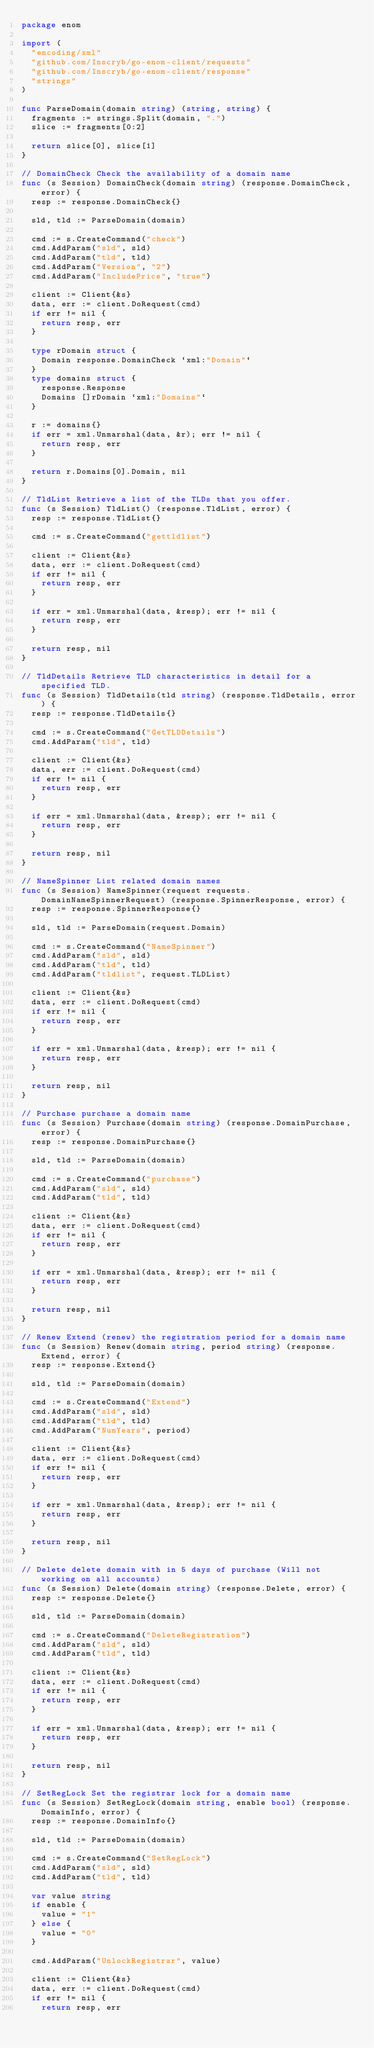Convert code to text. <code><loc_0><loc_0><loc_500><loc_500><_Go_>package enom

import (
	"encoding/xml"
	"github.com/Inscryb/go-enom-client/requests"
	"github.com/Inscryb/go-enom-client/response"
	"strings"
)

func ParseDomain(domain string) (string, string) {
	fragments := strings.Split(domain, ".")
	slice := fragments[0:2]

	return slice[0], slice[1]
}

// DomainCheck Check the availability of a domain name
func (s Session) DomainCheck(domain string) (response.DomainCheck, error) {
	resp := response.DomainCheck{}

	sld, tld := ParseDomain(domain)

	cmd := s.CreateCommand("check")
	cmd.AddParam("sld", sld)
	cmd.AddParam("tld", tld)
	cmd.AddParam("Version", "2")
	cmd.AddParam("IncludePrice", "true")

	client := Client{&s}
	data, err := client.DoRequest(cmd)
	if err != nil {
		return resp, err
	}

	type rDomain struct {
		Domain response.DomainCheck `xml:"Domain"`
	}
	type domains struct {
		response.Response
		Domains []rDomain `xml:"Domains"`
	}

	r := domains{}
	if err = xml.Unmarshal(data, &r); err != nil {
		return resp, err
	}

	return r.Domains[0].Domain, nil
}

// TldList Retrieve a list of the TLDs that you offer.
func (s Session) TldList() (response.TldList, error) {
	resp := response.TldList{}

	cmd := s.CreateCommand("gettldlist")

	client := Client{&s}
	data, err := client.DoRequest(cmd)
	if err != nil {
		return resp, err
	}

	if err = xml.Unmarshal(data, &resp); err != nil {
		return resp, err
	}

	return resp, nil
}

// TldDetails Retrieve TLD characteristics in detail for a specified TLD.
func (s Session) TldDetails(tld string) (response.TldDetails, error) {
	resp := response.TldDetails{}

	cmd := s.CreateCommand("GetTLDDetails")
	cmd.AddParam("tld", tld)

	client := Client{&s}
	data, err := client.DoRequest(cmd)
	if err != nil {
		return resp, err
	}

	if err = xml.Unmarshal(data, &resp); err != nil {
		return resp, err
	}

	return resp, nil
}

// NameSpinner List related domain names
func (s Session) NameSpinner(request requests.DomainNameSpinnerRequest) (response.SpinnerResponse, error) {
	resp := response.SpinnerResponse{}

	sld, tld := ParseDomain(request.Domain)

	cmd := s.CreateCommand("NameSpinner")
	cmd.AddParam("sld", sld)
	cmd.AddParam("tld", tld)
	cmd.AddParam("tldlist", request.TLDList)

	client := Client{&s}
	data, err := client.DoRequest(cmd)
	if err != nil {
		return resp, err
	}

	if err = xml.Unmarshal(data, &resp); err != nil {
		return resp, err
	}

	return resp, nil
}

// Purchase purchase a domain name
func (s Session) Purchase(domain string) (response.DomainPurchase, error) {
	resp := response.DomainPurchase{}

	sld, tld := ParseDomain(domain)

	cmd := s.CreateCommand("purchase")
	cmd.AddParam("sld", sld)
	cmd.AddParam("tld", tld)

	client := Client{&s}
	data, err := client.DoRequest(cmd)
	if err != nil {
		return resp, err
	}

	if err = xml.Unmarshal(data, &resp); err != nil {
		return resp, err
	}

	return resp, nil
}

// Renew Extend (renew) the registration period for a domain name
func (s Session) Renew(domain string, period string) (response.Extend, error) {
	resp := response.Extend{}

	sld, tld := ParseDomain(domain)

	cmd := s.CreateCommand("Extend")
	cmd.AddParam("sld", sld)
	cmd.AddParam("tld", tld)
	cmd.AddParam("NumYears", period)

	client := Client{&s}
	data, err := client.DoRequest(cmd)
	if err != nil {
		return resp, err
	}

	if err = xml.Unmarshal(data, &resp); err != nil {
		return resp, err
	}

	return resp, nil
}

// Delete delete domain with in 5 days of purchase (Will not working on all accounts)
func (s Session) Delete(domain string) (response.Delete, error) {
	resp := response.Delete{}

	sld, tld := ParseDomain(domain)

	cmd := s.CreateCommand("DeleteRegistration")
	cmd.AddParam("sld", sld)
	cmd.AddParam("tld", tld)

	client := Client{&s}
	data, err := client.DoRequest(cmd)
	if err != nil {
		return resp, err
	}

	if err = xml.Unmarshal(data, &resp); err != nil {
		return resp, err
	}

	return resp, nil
}

// SetRegLock Set the registrar lock for a domain name
func (s Session) SetRegLock(domain string, enable bool) (response.DomainInfo, error) {
	resp := response.DomainInfo{}

	sld, tld := ParseDomain(domain)

	cmd := s.CreateCommand("SetRegLock")
	cmd.AddParam("sld", sld)
	cmd.AddParam("tld", tld)

	var value string
	if enable {
		value = "1"
	} else {
		value = "0"
	}

	cmd.AddParam("UnlockRegistrar", value)

	client := Client{&s}
	data, err := client.DoRequest(cmd)
	if err != nil {
		return resp, err</code> 